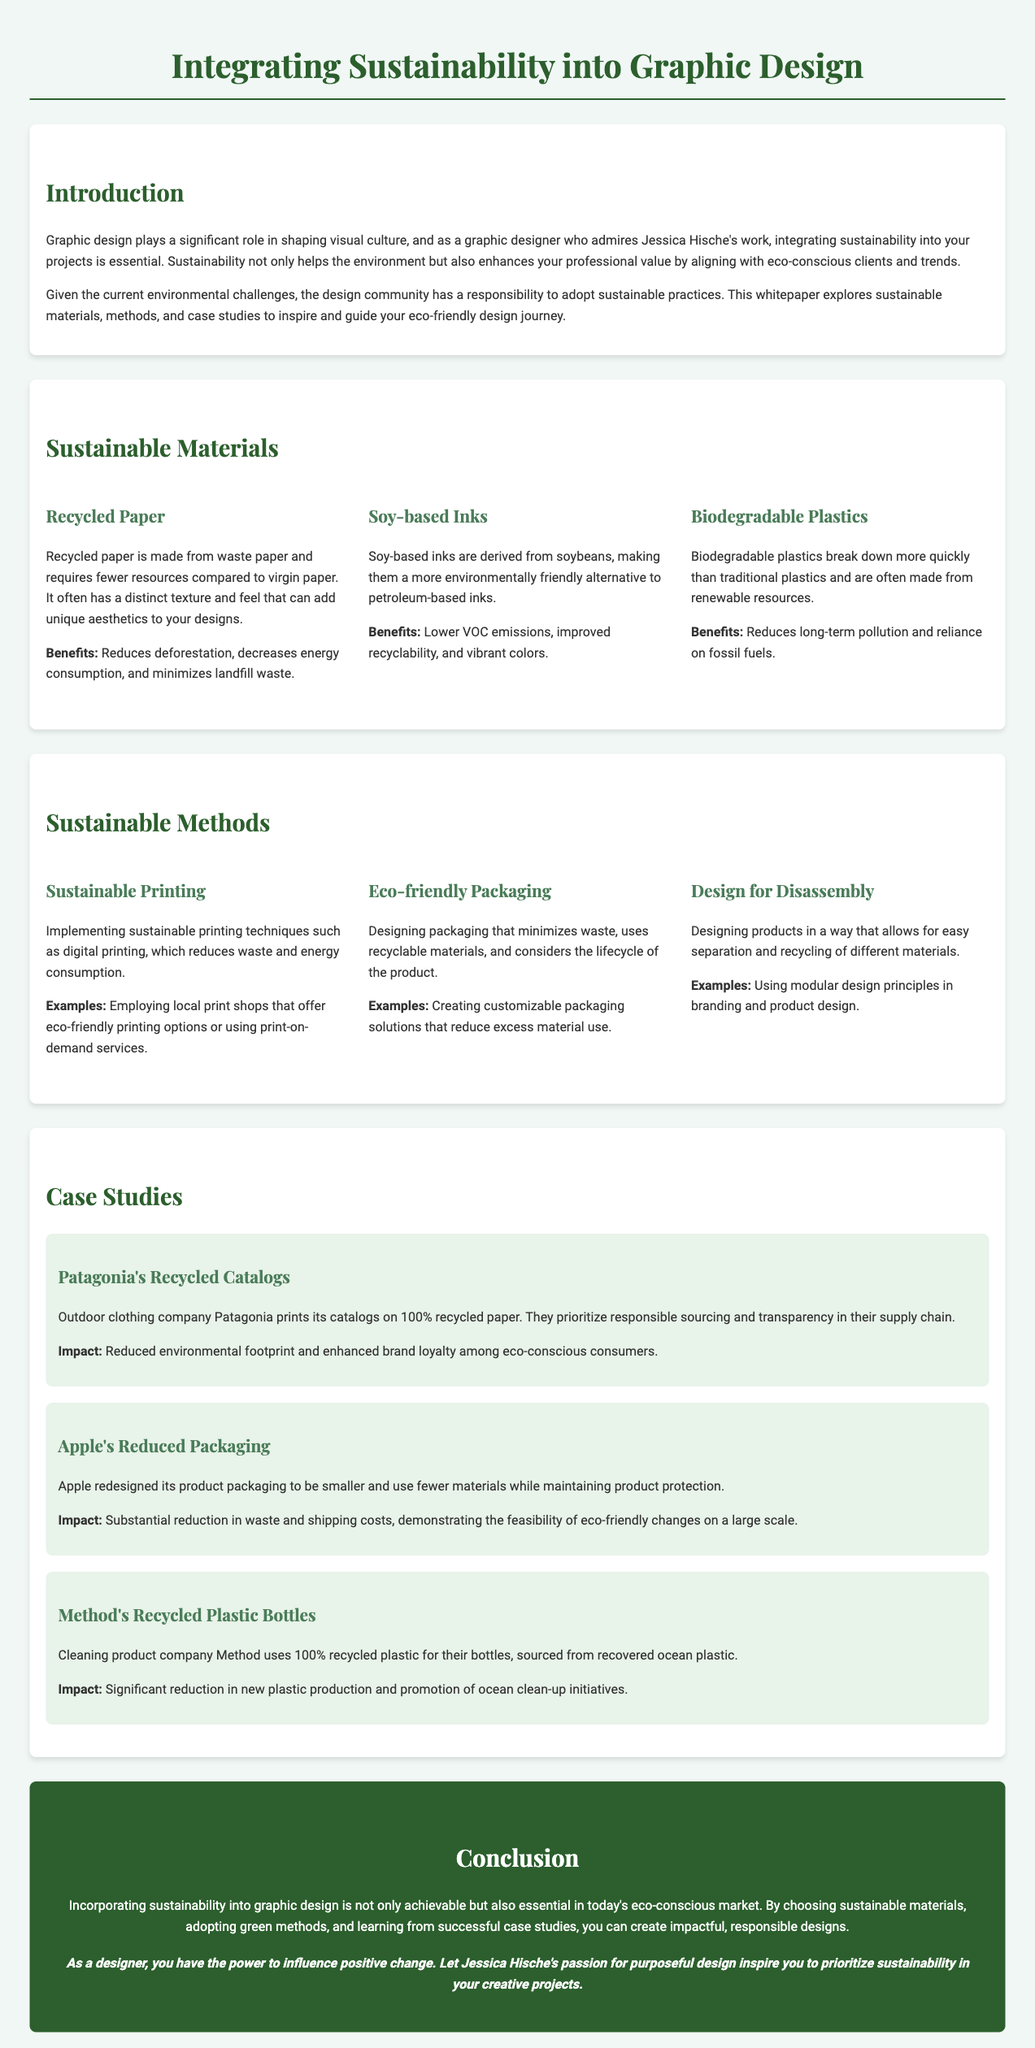What is the title of the whitepaper? The title is clearly stated at the beginning of the document.
Answer: Integrating Sustainability into Graphic Design What are two benefits of using recycled paper? The benefits are mentioned in the section about sustainable materials.
Answer: Reduces deforestation, decreases energy consumption What printing technique is emphasized for sustainability? The method is detailed under the sustainable methods section.
Answer: Sustainable printing Which company uses 100% recycled paper for its catalogs? This information is provided in the case studies section.
Answer: Patagonia What is a key impact of Apple's packaging redesign? The impact is discussed in the case study pertaining to Apple.
Answer: Substantial reduction in waste and shipping costs What type of ink is suggested as an eco-friendly alternative? This material is outlined in the sustainable materials section.
Answer: Soy-based inks What design principle is mentioned for easy recycling? This principle is clarified in the sustainable methods section.
Answer: Design for Disassembly What color is used for the conclusion section? The document specifies the color scheme for the conclusion section.
Answer: White (text on a green background) 